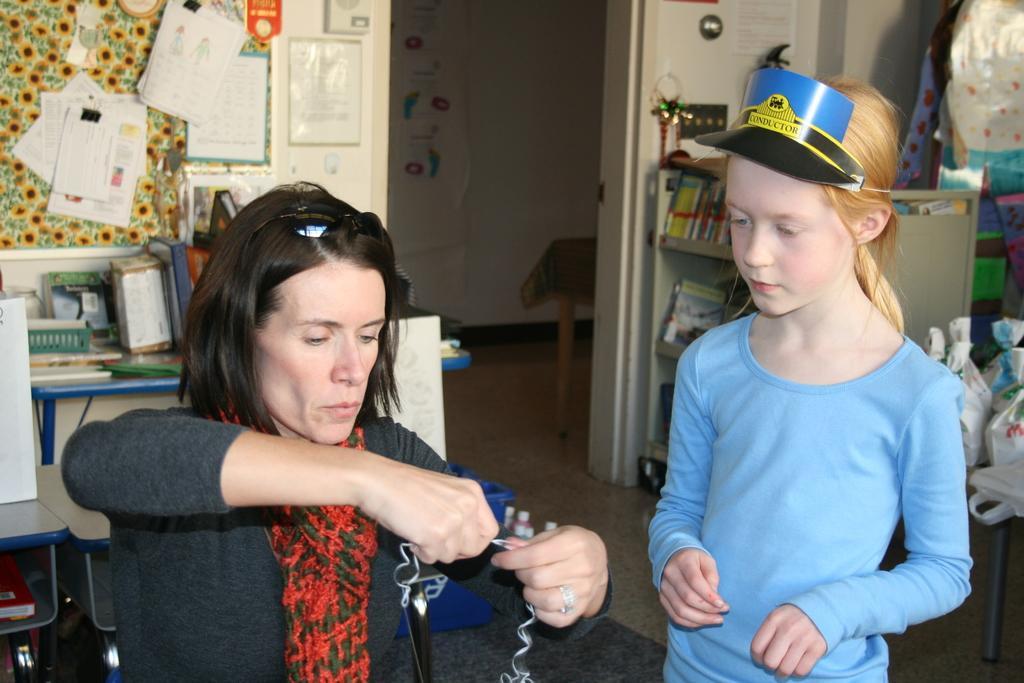In one or two sentences, can you explain what this image depicts? In this picture there is a woman at the bottom left and she is holding something. She is wearing a grey dress and red scarf. Towards the right, there is a girl wearing blue t shirt and a cap. In the center, there is an entrance. On both the sides of the image there are shelves with books. At the top left, there is a board with papers. 